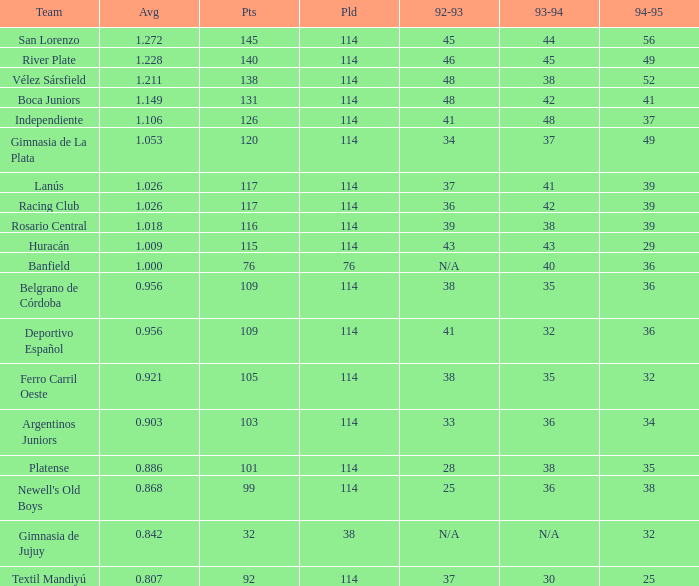Name the total number of 1992-93 for 115 points 1.0. 